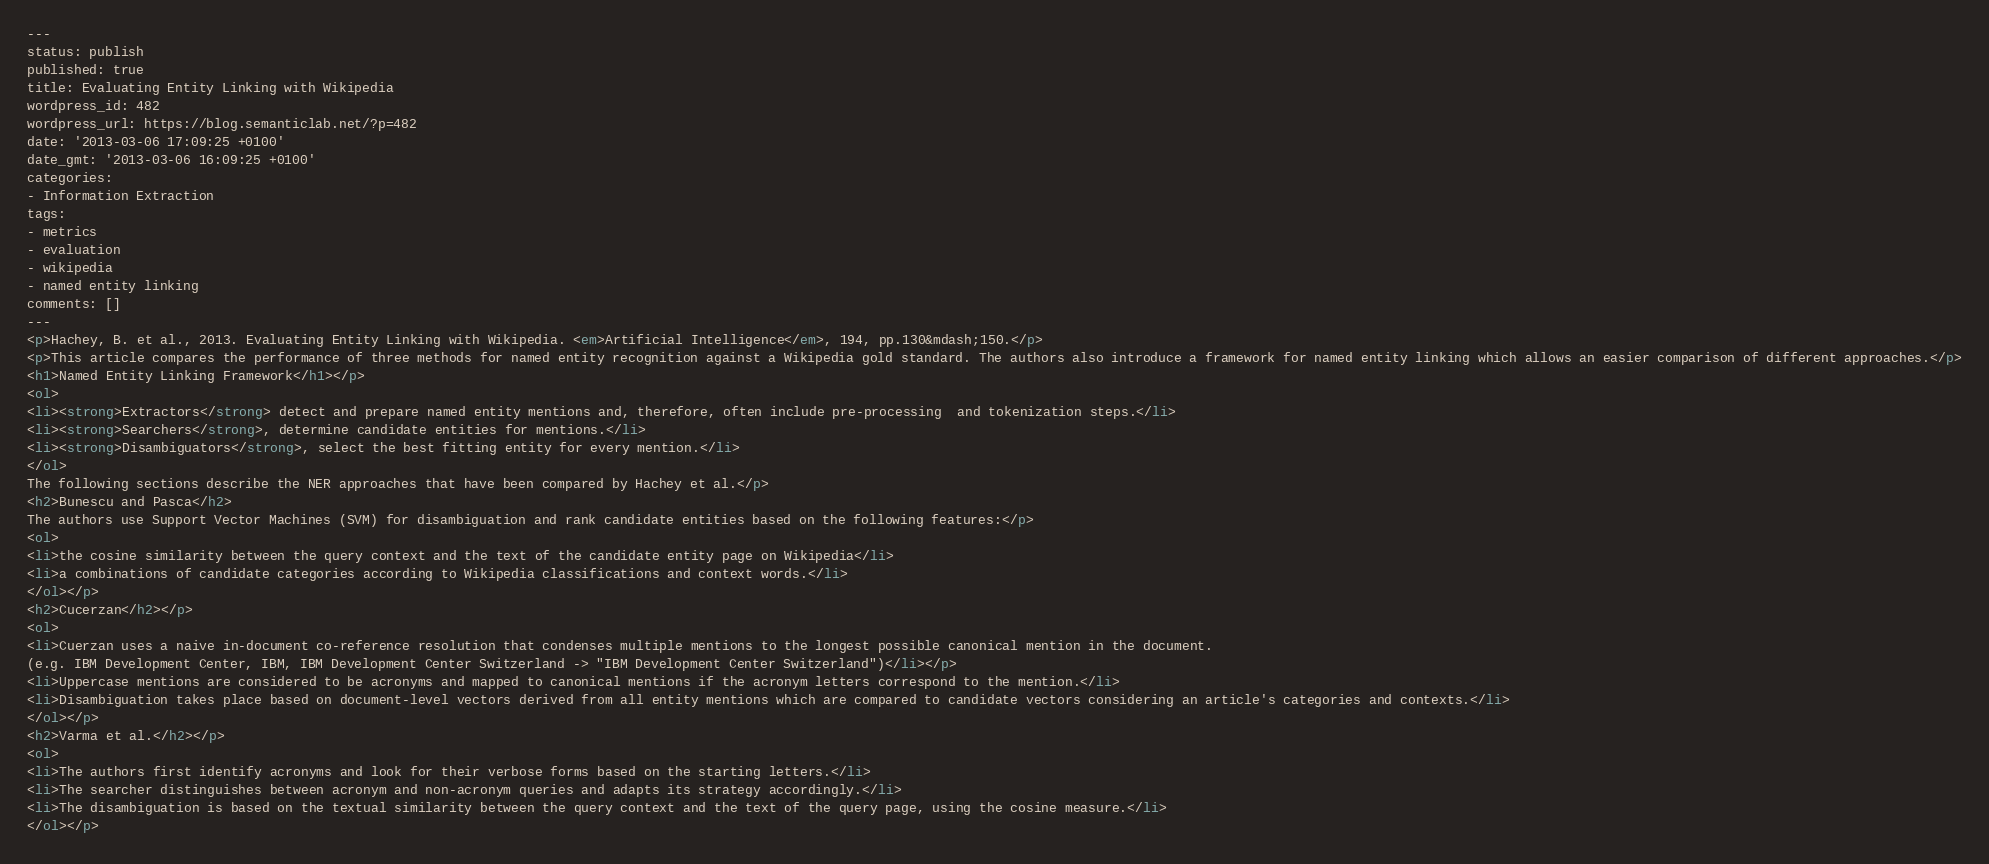Convert code to text. <code><loc_0><loc_0><loc_500><loc_500><_HTML_>---
status: publish
published: true
title: Evaluating Entity Linking with Wikipedia
wordpress_id: 482
wordpress_url: https://blog.semanticlab.net/?p=482
date: '2013-03-06 17:09:25 +0100'
date_gmt: '2013-03-06 16:09:25 +0100'
categories:
- Information Extraction
tags:
- metrics
- evaluation
- wikipedia
- named entity linking
comments: []
---
<p>Hachey, B. et al., 2013. Evaluating Entity Linking with Wikipedia. <em>Artificial Intelligence</em>, 194, pp.130&mdash;150.</p>
<p>This article compares the performance of three methods for named entity recognition against a Wikipedia gold standard. The authors also introduce a framework for named entity linking which allows an easier comparison of different approaches.</p>
<h1>Named Entity Linking Framework</h1></p>
<ol>
<li><strong>Extractors</strong> detect and prepare named entity mentions and, therefore, often include pre-processing  and tokenization steps.</li>
<li><strong>Searchers</strong>, determine candidate entities for mentions.</li>
<li><strong>Disambiguators</strong>, select the best fitting entity for every mention.</li>
</ol>
The following sections describe the NER approaches that have been compared by Hachey et al.</p>
<h2>Bunescu and Pasca</h2>
The authors use Support Vector Machines (SVM) for disambiguation and rank candidate entities based on the following features:</p>
<ol>
<li>the cosine similarity between the query context and the text of the candidate entity page on Wikipedia</li>
<li>a combinations of candidate categories according to Wikipedia classifications and context words.</li>
</ol></p>
<h2>Cucerzan</h2></p>
<ol>
<li>Cuerzan uses a naive in-document co-reference resolution that condenses multiple mentions to the longest possible canonical mention in the document.
(e.g. IBM Development Center, IBM, IBM Development Center Switzerland -> "IBM Development Center Switzerland")</li></p>
<li>Uppercase mentions are considered to be acronyms and mapped to canonical mentions if the acronym letters correspond to the mention.</li>
<li>Disambiguation takes place based on document-level vectors derived from all entity mentions which are compared to candidate vectors considering an article's categories and contexts.</li>
</ol></p>
<h2>Varma et al.</h2></p>
<ol>
<li>The authors first identify acronyms and look for their verbose forms based on the starting letters.</li>
<li>The searcher distinguishes between acronym and non-acronym queries and adapts its strategy accordingly.</li>
<li>The disambiguation is based on the textual similarity between the query context and the text of the query page, using the cosine measure.</li>
</ol></p></code> 